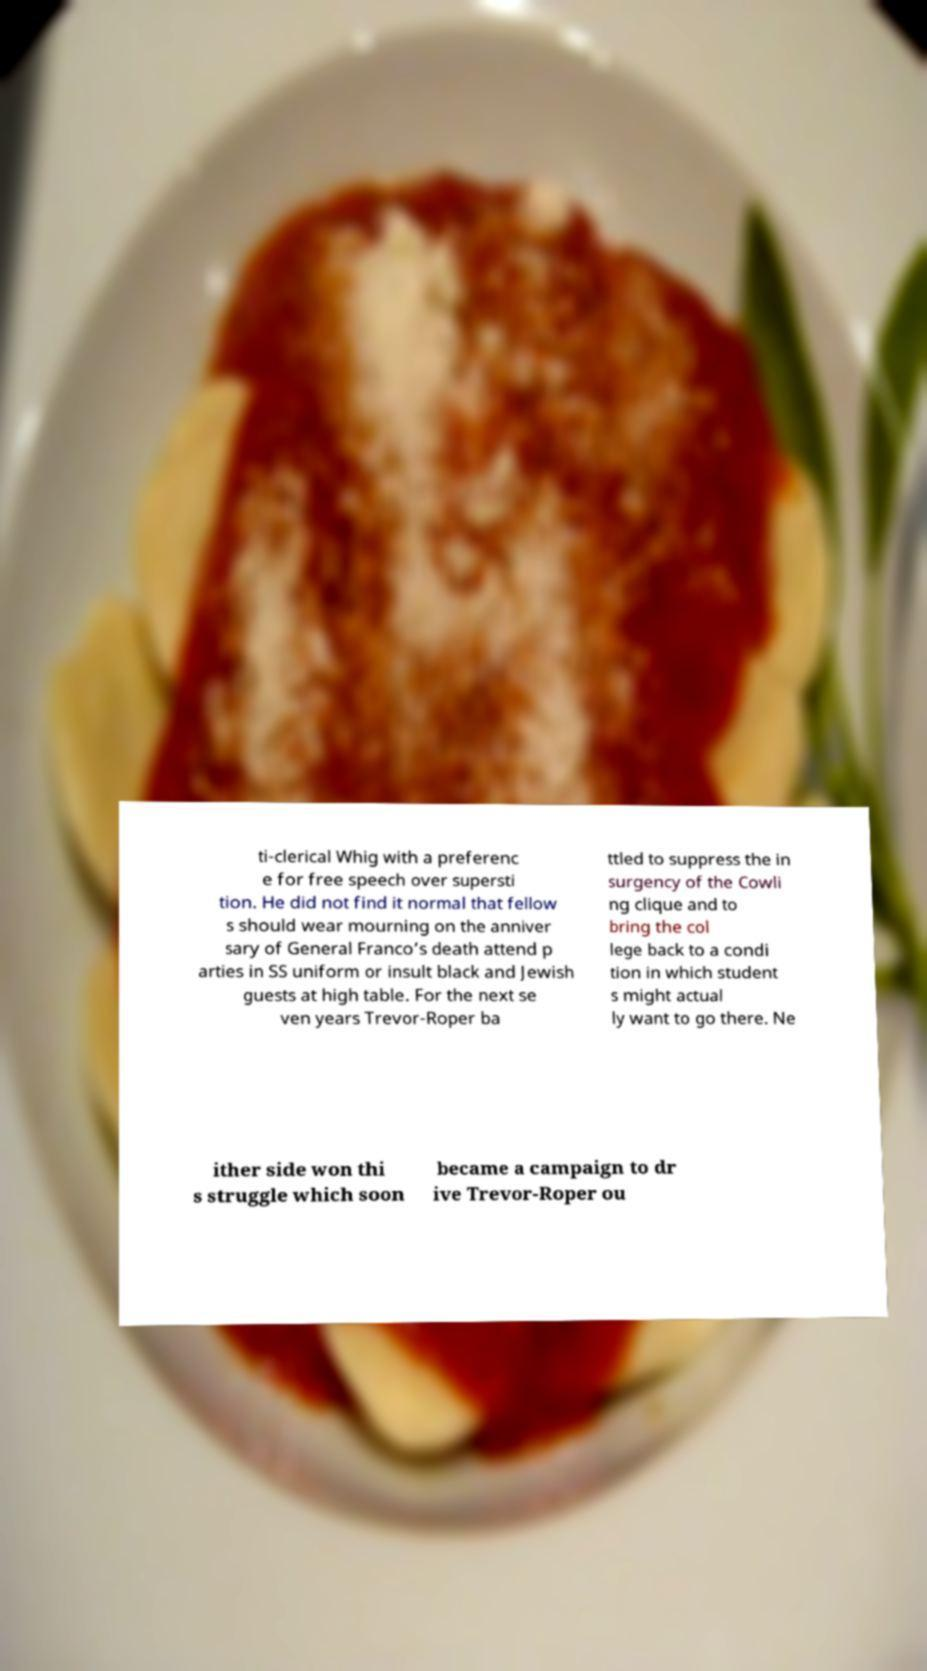Can you read and provide the text displayed in the image?This photo seems to have some interesting text. Can you extract and type it out for me? ti-clerical Whig with a preferenc e for free speech over supersti tion. He did not find it normal that fellow s should wear mourning on the anniver sary of General Franco’s death attend p arties in SS uniform or insult black and Jewish guests at high table. For the next se ven years Trevor-Roper ba ttled to suppress the in surgency of the Cowli ng clique and to bring the col lege back to a condi tion in which student s might actual ly want to go there. Ne ither side won thi s struggle which soon became a campaign to dr ive Trevor-Roper ou 